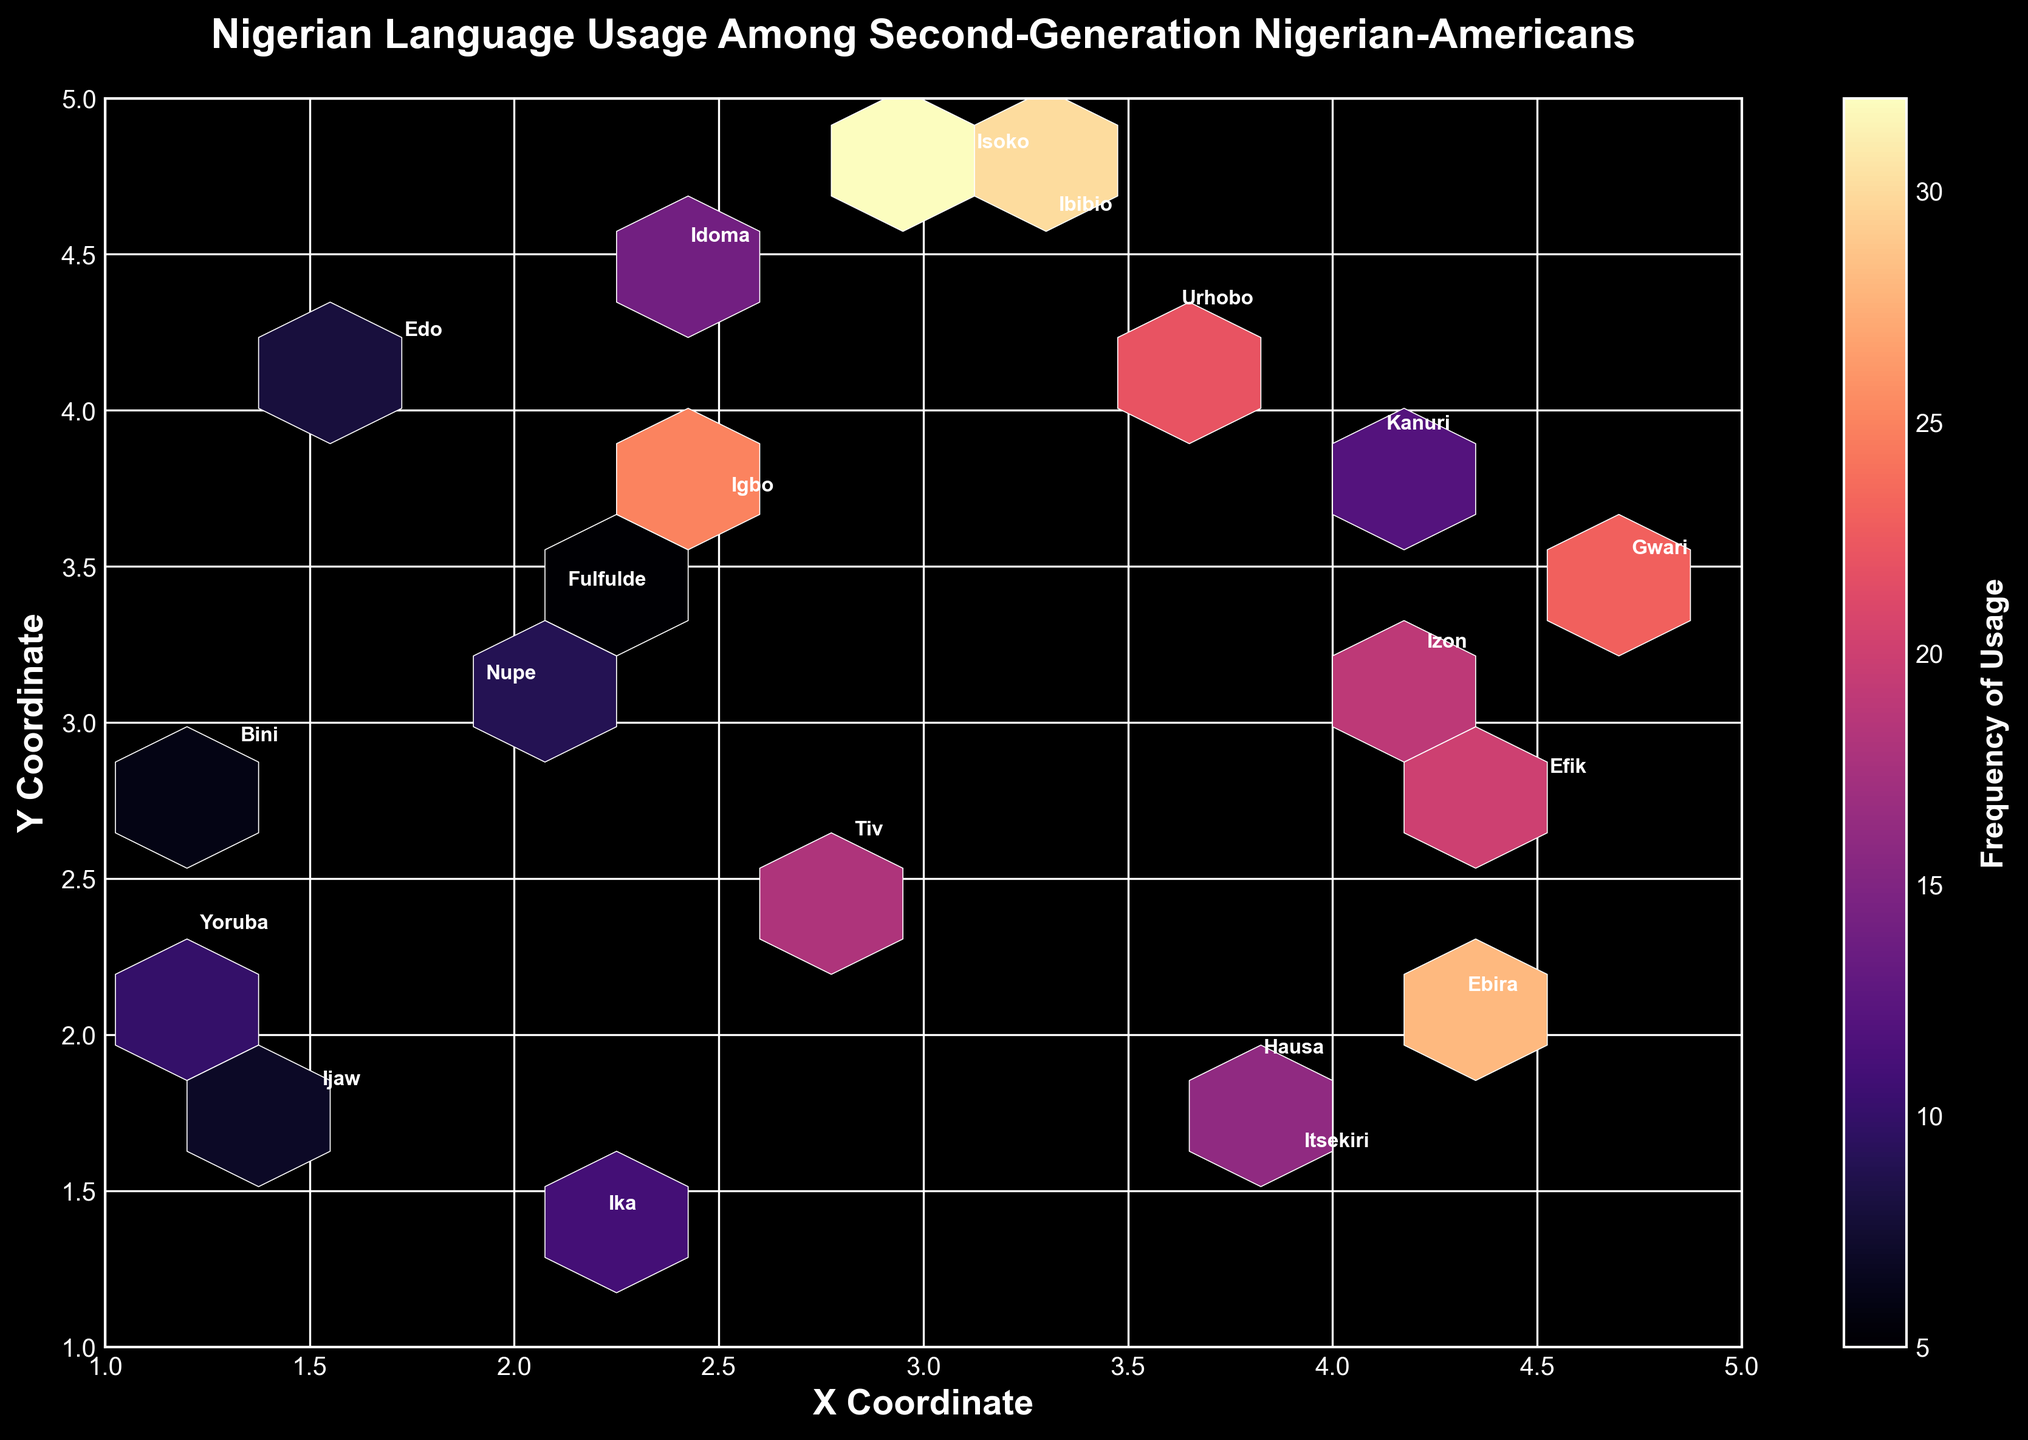What's the title of the hexbin plot? The title is located at the top of the plot and usually summarizes the main data topic.
Answer: Nigerian Language Usage Among Second-Generation Nigerian-Americans Which axis represents the X Coordinate? The X Coordinate is represented by the horizontal axis, which is labeled 'X Coordinate' at the bottom of the plot.
Answer: The horizontal axis Which axis represents the Y Coordinate? The Y Coordinate is represented by the vertical axis, which is labeled 'Y Coordinate' on the left side of the plot.
Answer: The vertical axis What does the color bar represent? The color bar, located usually on the right side of the plot, indicates the 'Frequency of Usage' with a color gradient.
Answer: Frequency of Usage Which regional dialect has the highest reported frequency of usage according to the plot? By observing the color bar and the annotated points, the one with the darkest color corresponds to the highest frequency. 'Isoko' has the highest frequency of 32.
Answer: Isoko What is the frequency of usage for the Yoruba dialect? The Yoruba dialect is annotated in the plot at coordinates (1.2, 2.3). The color bar provides the corresponding frequency, which is 10.
Answer: 10 Identify which dialects are used more frequently by individuals older than 15. The ages and corresponding dialect frequencies can be checked: Hausa (15), Efik (20), Urhobo (22), Ibibio (30), Ebira (28), Izon (19), Gwari (23), Isoko (32).
Answer: Hausa, Efik, Urhobo, Ibibio, Ebira, Izon, Gwari, Isoko Compare the frequency of usage between 'Igbo' and 'Bini' dialects. Which one is higher? Locate 'Igbo' (2.5, 3.7) and 'Bini' (1.3, 2.9). The frequency for Igbo is 25, and for Bini, it is 6. Igbo has a higher frequency.
Answer: Igbo What is the average frequency of usage for the ages 10, 14, and 18? Find the frequencies for these ages: Idoma (14), Kanuri (12), Hausa (15). Calculate the average as (14 + 12 + 15)/3 = 13.67
Answer: 13.67 